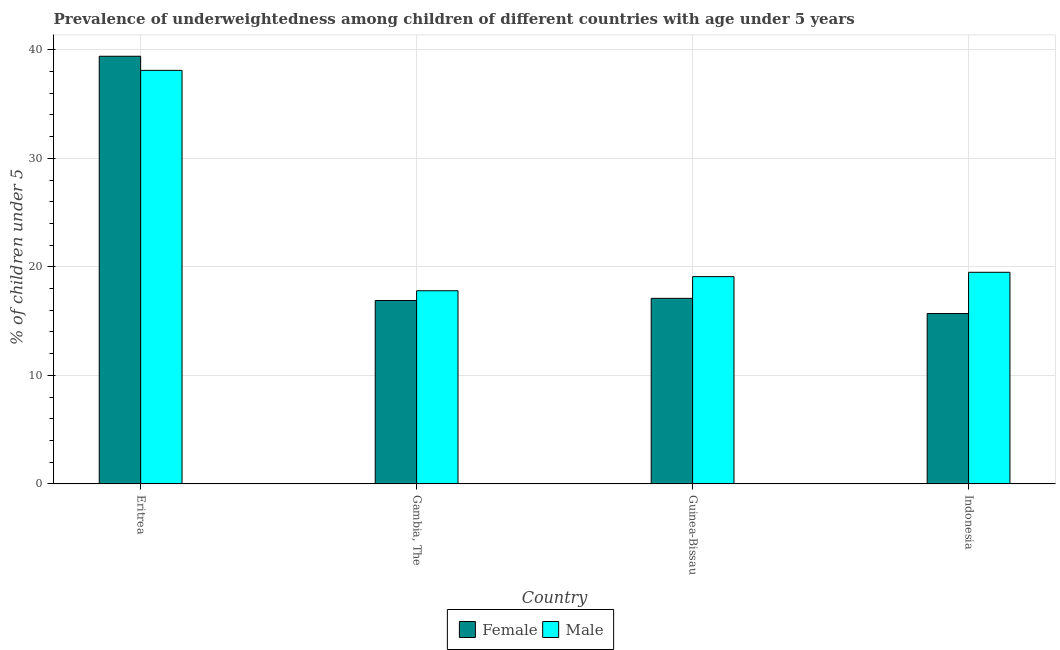How many different coloured bars are there?
Keep it short and to the point. 2. How many groups of bars are there?
Provide a succinct answer. 4. What is the percentage of underweighted male children in Gambia, The?
Give a very brief answer. 17.8. Across all countries, what is the maximum percentage of underweighted male children?
Your answer should be compact. 38.1. Across all countries, what is the minimum percentage of underweighted female children?
Your answer should be compact. 15.7. In which country was the percentage of underweighted male children maximum?
Keep it short and to the point. Eritrea. In which country was the percentage of underweighted female children minimum?
Provide a succinct answer. Indonesia. What is the total percentage of underweighted male children in the graph?
Provide a succinct answer. 94.5. What is the difference between the percentage of underweighted female children in Gambia, The and that in Indonesia?
Offer a very short reply. 1.2. What is the difference between the percentage of underweighted female children in Gambia, The and the percentage of underweighted male children in Indonesia?
Your answer should be very brief. -2.6. What is the average percentage of underweighted male children per country?
Provide a short and direct response. 23.62. What is the difference between the percentage of underweighted female children and percentage of underweighted male children in Eritrea?
Your answer should be very brief. 1.3. In how many countries, is the percentage of underweighted male children greater than 34 %?
Offer a very short reply. 1. What is the ratio of the percentage of underweighted male children in Eritrea to that in Guinea-Bissau?
Make the answer very short. 1.99. What is the difference between the highest and the second highest percentage of underweighted female children?
Offer a very short reply. 22.3. What is the difference between the highest and the lowest percentage of underweighted female children?
Your response must be concise. 23.7. In how many countries, is the percentage of underweighted male children greater than the average percentage of underweighted male children taken over all countries?
Provide a short and direct response. 1. What does the 1st bar from the right in Gambia, The represents?
Offer a terse response. Male. How many countries are there in the graph?
Provide a succinct answer. 4. What is the difference between two consecutive major ticks on the Y-axis?
Give a very brief answer. 10. Does the graph contain any zero values?
Provide a succinct answer. No. Where does the legend appear in the graph?
Provide a short and direct response. Bottom center. How are the legend labels stacked?
Your answer should be compact. Horizontal. What is the title of the graph?
Provide a short and direct response. Prevalence of underweightedness among children of different countries with age under 5 years. What is the label or title of the Y-axis?
Provide a short and direct response.  % of children under 5. What is the  % of children under 5 in Female in Eritrea?
Offer a terse response. 39.4. What is the  % of children under 5 in Male in Eritrea?
Provide a short and direct response. 38.1. What is the  % of children under 5 of Female in Gambia, The?
Offer a very short reply. 16.9. What is the  % of children under 5 of Male in Gambia, The?
Offer a terse response. 17.8. What is the  % of children under 5 in Female in Guinea-Bissau?
Give a very brief answer. 17.1. What is the  % of children under 5 of Male in Guinea-Bissau?
Provide a short and direct response. 19.1. What is the  % of children under 5 in Female in Indonesia?
Offer a very short reply. 15.7. Across all countries, what is the maximum  % of children under 5 in Female?
Offer a terse response. 39.4. Across all countries, what is the maximum  % of children under 5 in Male?
Keep it short and to the point. 38.1. Across all countries, what is the minimum  % of children under 5 in Female?
Your answer should be compact. 15.7. Across all countries, what is the minimum  % of children under 5 of Male?
Your answer should be compact. 17.8. What is the total  % of children under 5 of Female in the graph?
Make the answer very short. 89.1. What is the total  % of children under 5 of Male in the graph?
Offer a very short reply. 94.5. What is the difference between the  % of children under 5 of Male in Eritrea and that in Gambia, The?
Keep it short and to the point. 20.3. What is the difference between the  % of children under 5 of Female in Eritrea and that in Guinea-Bissau?
Keep it short and to the point. 22.3. What is the difference between the  % of children under 5 in Male in Eritrea and that in Guinea-Bissau?
Your answer should be compact. 19. What is the difference between the  % of children under 5 in Female in Eritrea and that in Indonesia?
Your answer should be very brief. 23.7. What is the difference between the  % of children under 5 in Female in Gambia, The and that in Indonesia?
Your response must be concise. 1.2. What is the difference between the  % of children under 5 of Male in Gambia, The and that in Indonesia?
Ensure brevity in your answer.  -1.7. What is the difference between the  % of children under 5 of Male in Guinea-Bissau and that in Indonesia?
Your answer should be compact. -0.4. What is the difference between the  % of children under 5 in Female in Eritrea and the  % of children under 5 in Male in Gambia, The?
Provide a short and direct response. 21.6. What is the difference between the  % of children under 5 of Female in Eritrea and the  % of children under 5 of Male in Guinea-Bissau?
Your answer should be very brief. 20.3. What is the difference between the  % of children under 5 of Female in Eritrea and the  % of children under 5 of Male in Indonesia?
Your response must be concise. 19.9. What is the difference between the  % of children under 5 of Female in Gambia, The and the  % of children under 5 of Male in Indonesia?
Make the answer very short. -2.6. What is the difference between the  % of children under 5 in Female in Guinea-Bissau and the  % of children under 5 in Male in Indonesia?
Your answer should be very brief. -2.4. What is the average  % of children under 5 of Female per country?
Keep it short and to the point. 22.27. What is the average  % of children under 5 in Male per country?
Provide a short and direct response. 23.62. What is the difference between the  % of children under 5 of Female and  % of children under 5 of Male in Eritrea?
Your response must be concise. 1.3. What is the ratio of the  % of children under 5 of Female in Eritrea to that in Gambia, The?
Keep it short and to the point. 2.33. What is the ratio of the  % of children under 5 of Male in Eritrea to that in Gambia, The?
Your answer should be very brief. 2.14. What is the ratio of the  % of children under 5 of Female in Eritrea to that in Guinea-Bissau?
Keep it short and to the point. 2.3. What is the ratio of the  % of children under 5 in Male in Eritrea to that in Guinea-Bissau?
Give a very brief answer. 1.99. What is the ratio of the  % of children under 5 of Female in Eritrea to that in Indonesia?
Your answer should be very brief. 2.51. What is the ratio of the  % of children under 5 in Male in Eritrea to that in Indonesia?
Provide a short and direct response. 1.95. What is the ratio of the  % of children under 5 of Female in Gambia, The to that in Guinea-Bissau?
Your response must be concise. 0.99. What is the ratio of the  % of children under 5 of Male in Gambia, The to that in Guinea-Bissau?
Offer a terse response. 0.93. What is the ratio of the  % of children under 5 in Female in Gambia, The to that in Indonesia?
Provide a short and direct response. 1.08. What is the ratio of the  % of children under 5 of Male in Gambia, The to that in Indonesia?
Make the answer very short. 0.91. What is the ratio of the  % of children under 5 of Female in Guinea-Bissau to that in Indonesia?
Ensure brevity in your answer.  1.09. What is the ratio of the  % of children under 5 of Male in Guinea-Bissau to that in Indonesia?
Keep it short and to the point. 0.98. What is the difference between the highest and the second highest  % of children under 5 of Female?
Your response must be concise. 22.3. What is the difference between the highest and the lowest  % of children under 5 in Female?
Give a very brief answer. 23.7. What is the difference between the highest and the lowest  % of children under 5 of Male?
Give a very brief answer. 20.3. 